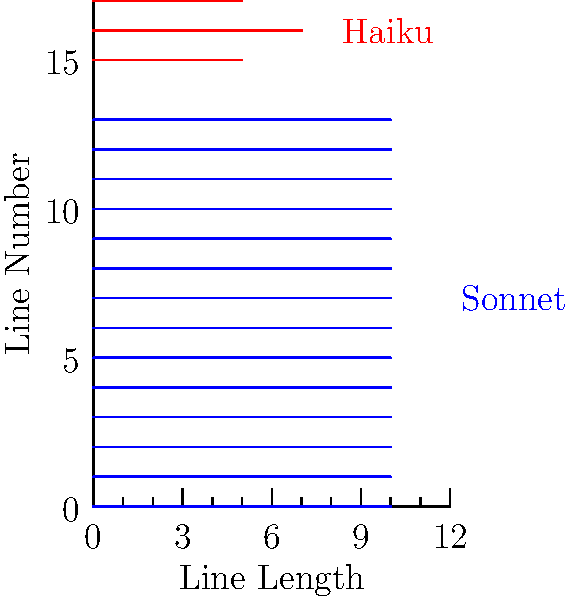Based on the visual representation of line lengths, which poetic structure is characterized by 14 lines of equal length, and which one has a distinct 5-7-5 syllable pattern? To answer this question, we need to analyze the visual representation of line lengths for two different poetic structures:

1. The blue lines represent one structure:
   - There are 14 lines in total.
   - All lines are of equal length (10 units).
   - This pattern is consistent with a sonnet, which typically has 14 lines of similar length.

2. The red lines represent another structure:
   - There are 3 lines in total.
   - The line lengths follow a distinct pattern: 5 units, 7 units, 5 units.
   - This 5-7-5 pattern is characteristic of a haiku, which traditionally has 5 syllables in the first line, 7 in the second, and 5 in the third.

3. Comparing the two structures:
   - The 14-line structure with equal line lengths matches the description of a sonnet.
   - The 3-line structure with the 5-7-5 pattern matches the description of a haiku.

Therefore, the sonnet is characterized by 14 lines of equal length, and the haiku has the distinct 5-7-5 syllable pattern.
Answer: Sonnet (14 equal lines), Haiku (5-7-5 pattern) 